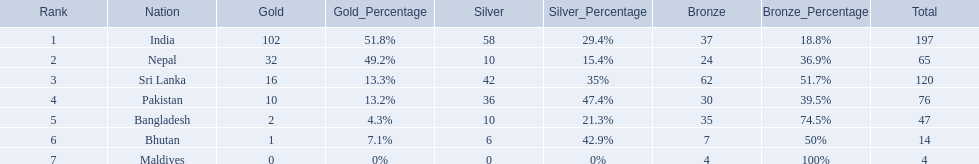What nations took part in 1999 south asian games? India, Nepal, Sri Lanka, Pakistan, Bangladesh, Bhutan, Maldives. Of those who earned gold medals? India, Nepal, Sri Lanka, Pakistan, Bangladesh, Bhutan. Which nation didn't earn any gold medals? Maldives. 